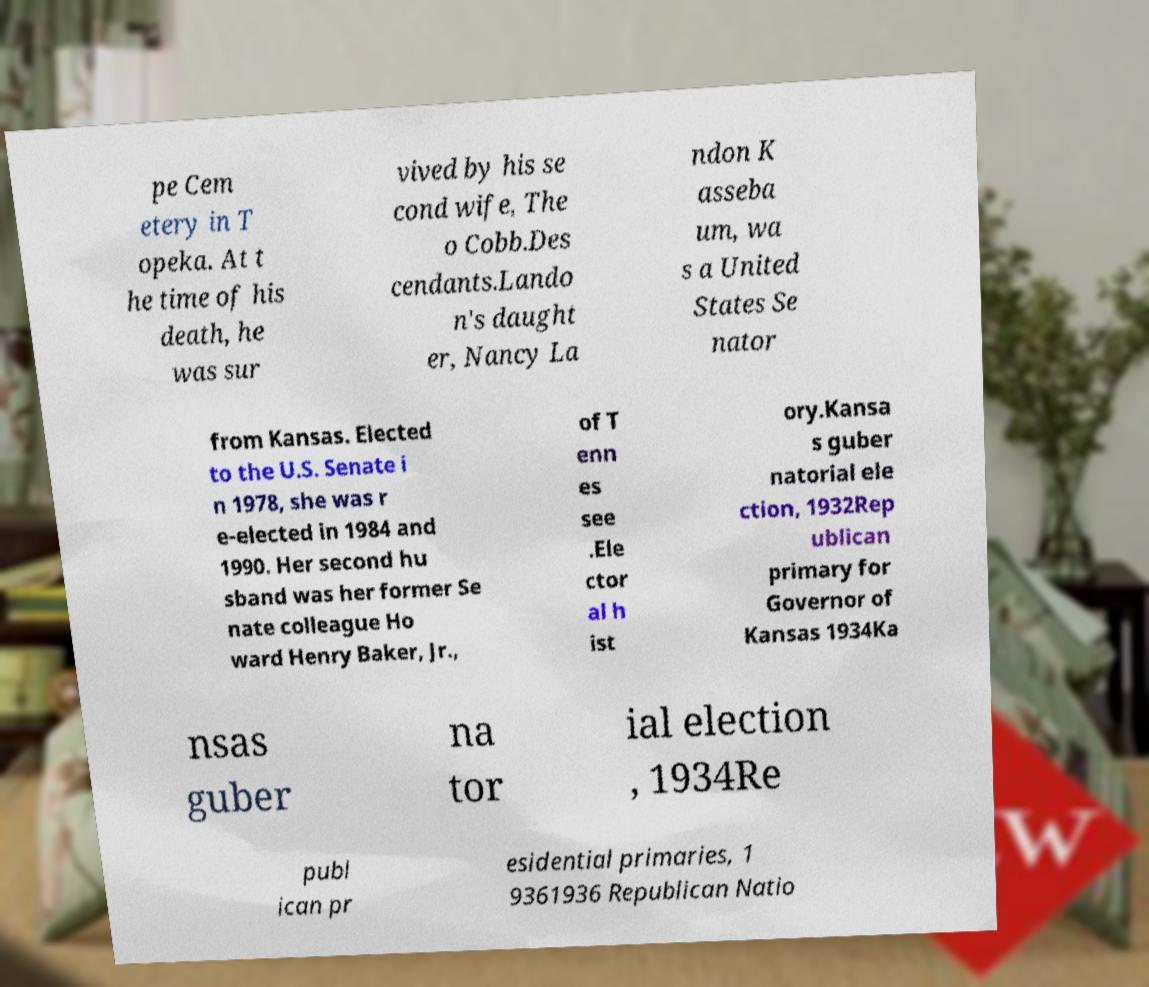There's text embedded in this image that I need extracted. Can you transcribe it verbatim? pe Cem etery in T opeka. At t he time of his death, he was sur vived by his se cond wife, The o Cobb.Des cendants.Lando n's daught er, Nancy La ndon K asseba um, wa s a United States Se nator from Kansas. Elected to the U.S. Senate i n 1978, she was r e-elected in 1984 and 1990. Her second hu sband was her former Se nate colleague Ho ward Henry Baker, Jr., of T enn es see .Ele ctor al h ist ory.Kansa s guber natorial ele ction, 1932Rep ublican primary for Governor of Kansas 1934Ka nsas guber na tor ial election , 1934Re publ ican pr esidential primaries, 1 9361936 Republican Natio 